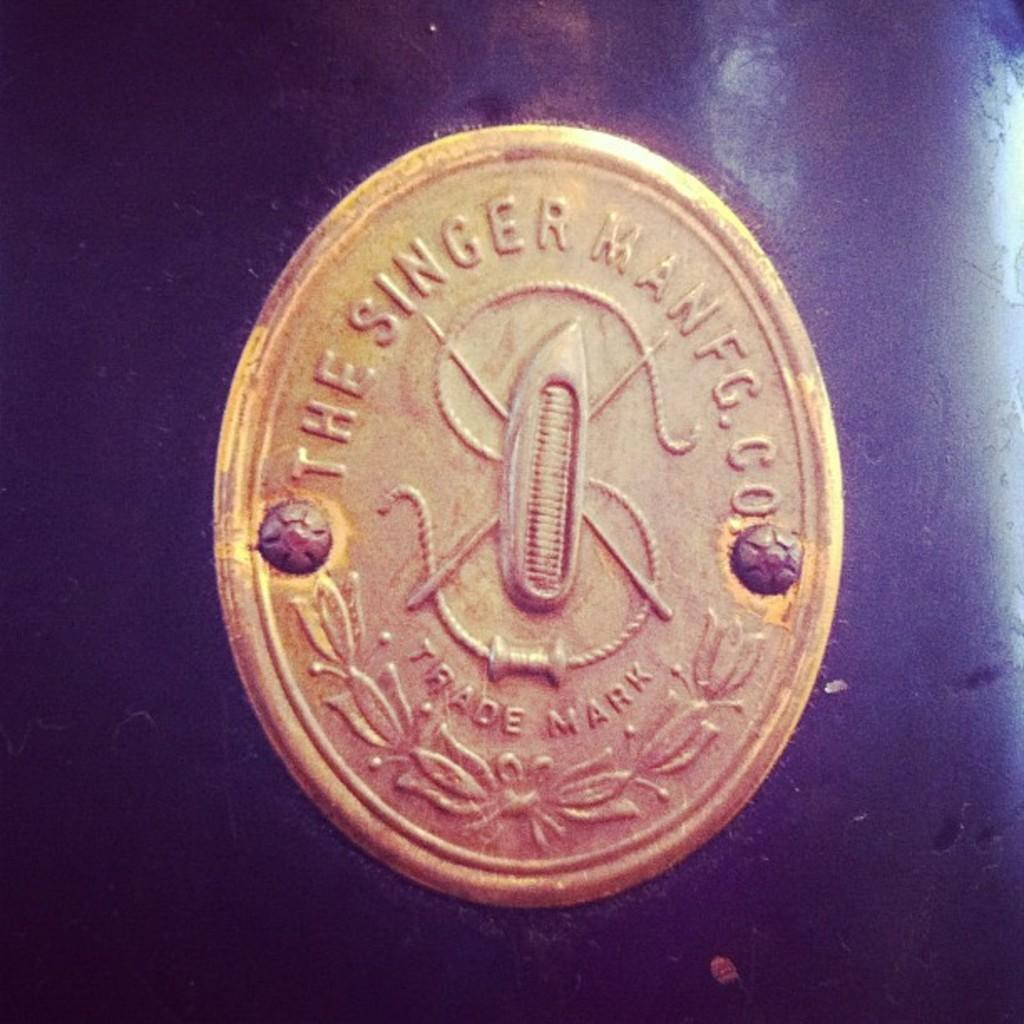<image>
Offer a succinct explanation of the picture presented. A logo of The SInger Manufacturing Company with trade mark 